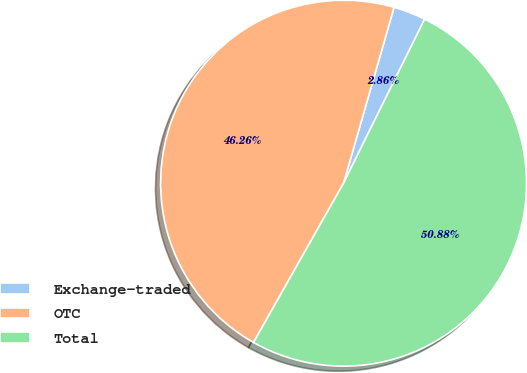<chart> <loc_0><loc_0><loc_500><loc_500><pie_chart><fcel>Exchange-traded<fcel>OTC<fcel>Total<nl><fcel>2.86%<fcel>46.26%<fcel>50.88%<nl></chart> 